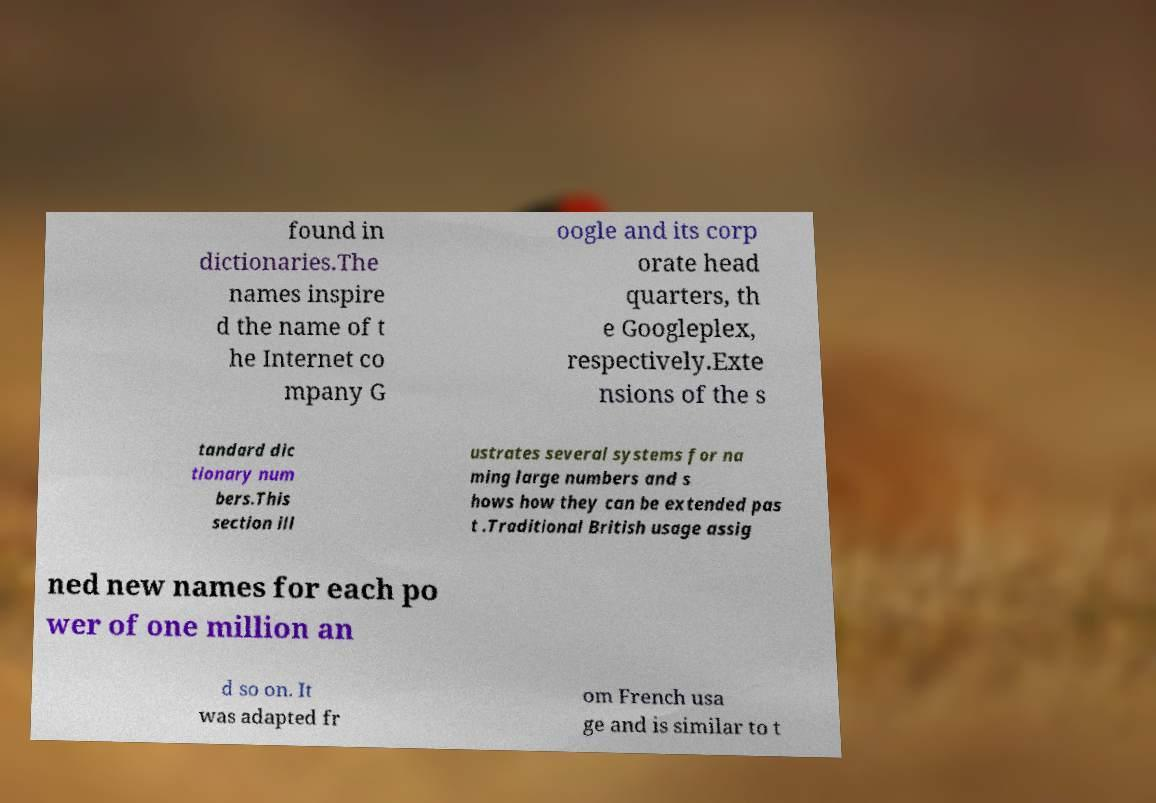Could you extract and type out the text from this image? found in dictionaries.The names inspire d the name of t he Internet co mpany G oogle and its corp orate head quarters, th e Googleplex, respectively.Exte nsions of the s tandard dic tionary num bers.This section ill ustrates several systems for na ming large numbers and s hows how they can be extended pas t .Traditional British usage assig ned new names for each po wer of one million an d so on. It was adapted fr om French usa ge and is similar to t 